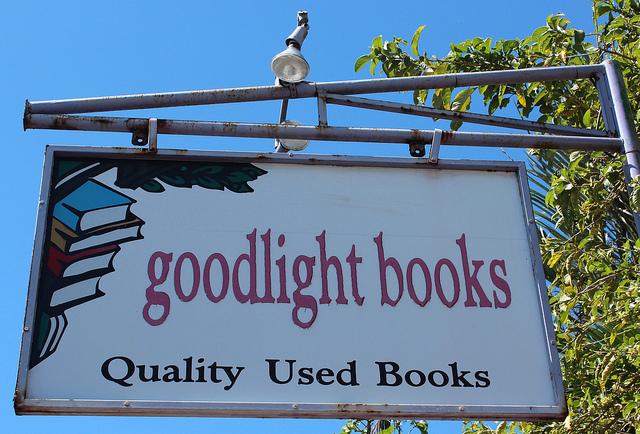What kind of books are being sold?
Quick response, please. Used. What are the wording?
Be succinct. Goodlight books quality used books. How many books are on the sign?
Quick response, please. 4. 